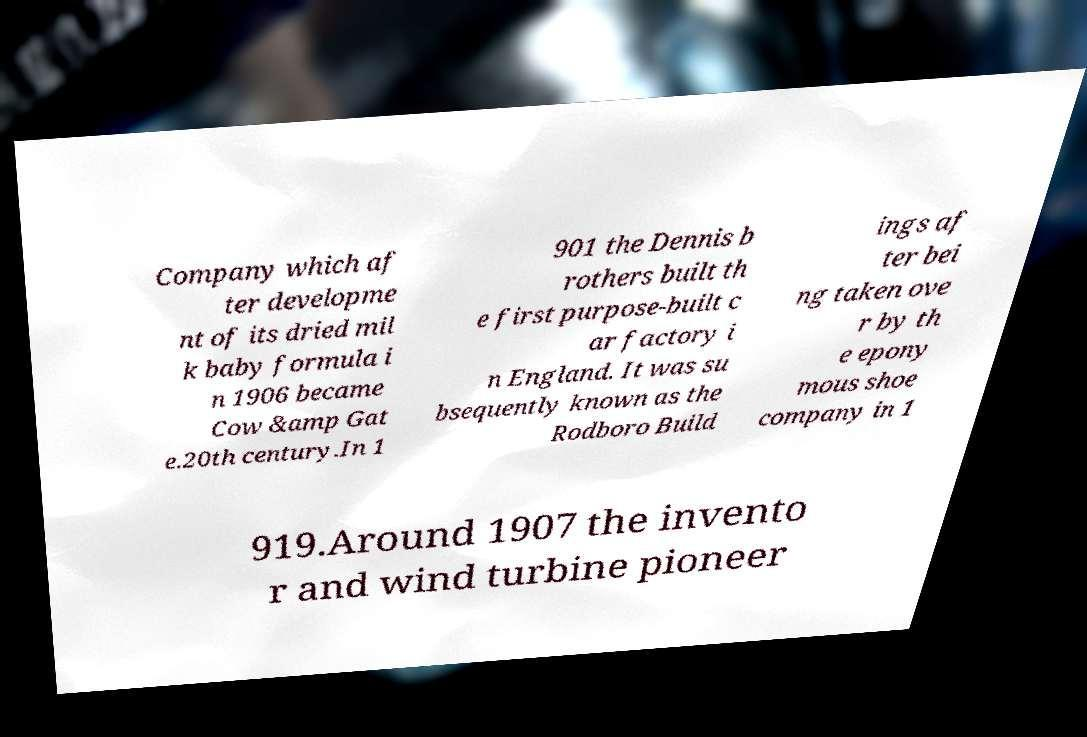There's text embedded in this image that I need extracted. Can you transcribe it verbatim? Company which af ter developme nt of its dried mil k baby formula i n 1906 became Cow &amp Gat e.20th century.In 1 901 the Dennis b rothers built th e first purpose-built c ar factory i n England. It was su bsequently known as the Rodboro Build ings af ter bei ng taken ove r by th e epony mous shoe company in 1 919.Around 1907 the invento r and wind turbine pioneer 